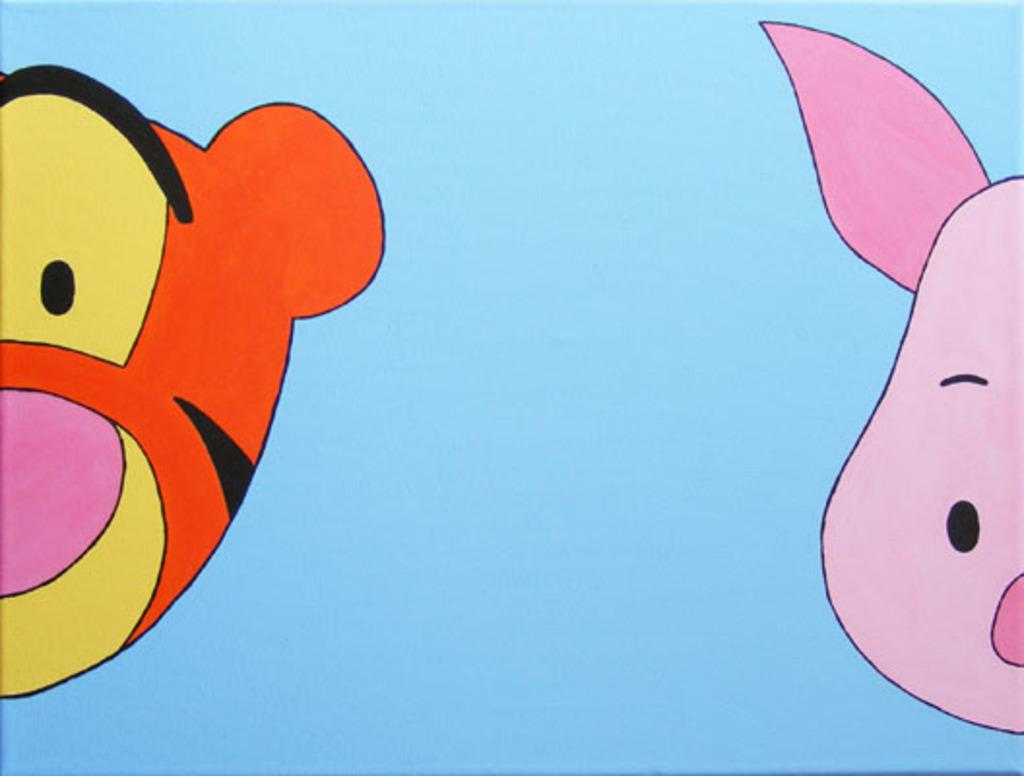What type of animals are depicted in the cartoon pictures in the image? There is a cartoon picture of a pig and a cartoon picture of a tiger in the image. Can you describe the characteristics of the cartoon pictures? The cartoon pictures are of a pig and a tiger, which are both animals. What type of guitar is being played by the pig in the image? There is no guitar present in the image, as it only features cartoon pictures of a pig and a tiger. 